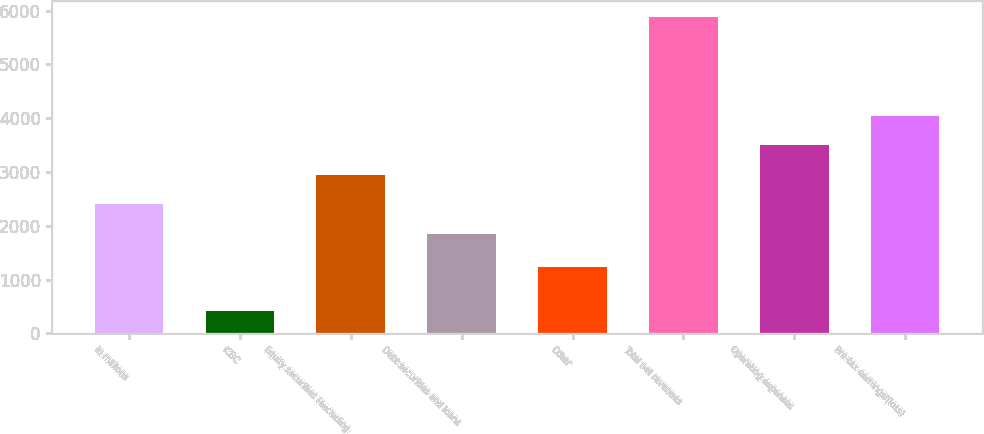<chart> <loc_0><loc_0><loc_500><loc_500><bar_chart><fcel>in millions<fcel>ICBC<fcel>Equity securities (excluding<fcel>Debt securities and loans<fcel>Other<fcel>Total net revenues<fcel>Operating expenses<fcel>Pre-tax earnings/(loss)<nl><fcel>2398.3<fcel>408<fcel>2946.6<fcel>1850<fcel>1241<fcel>5891<fcel>3494.9<fcel>4043.2<nl></chart> 